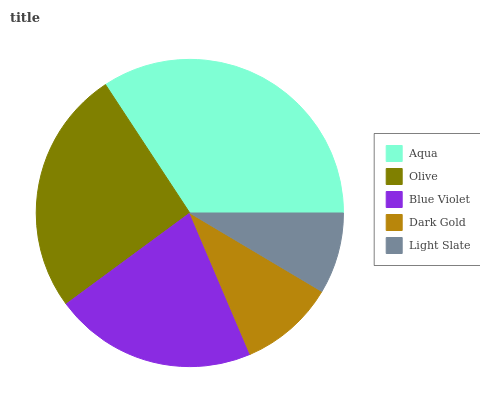Is Light Slate the minimum?
Answer yes or no. Yes. Is Aqua the maximum?
Answer yes or no. Yes. Is Olive the minimum?
Answer yes or no. No. Is Olive the maximum?
Answer yes or no. No. Is Aqua greater than Olive?
Answer yes or no. Yes. Is Olive less than Aqua?
Answer yes or no. Yes. Is Olive greater than Aqua?
Answer yes or no. No. Is Aqua less than Olive?
Answer yes or no. No. Is Blue Violet the high median?
Answer yes or no. Yes. Is Blue Violet the low median?
Answer yes or no. Yes. Is Dark Gold the high median?
Answer yes or no. No. Is Olive the low median?
Answer yes or no. No. 